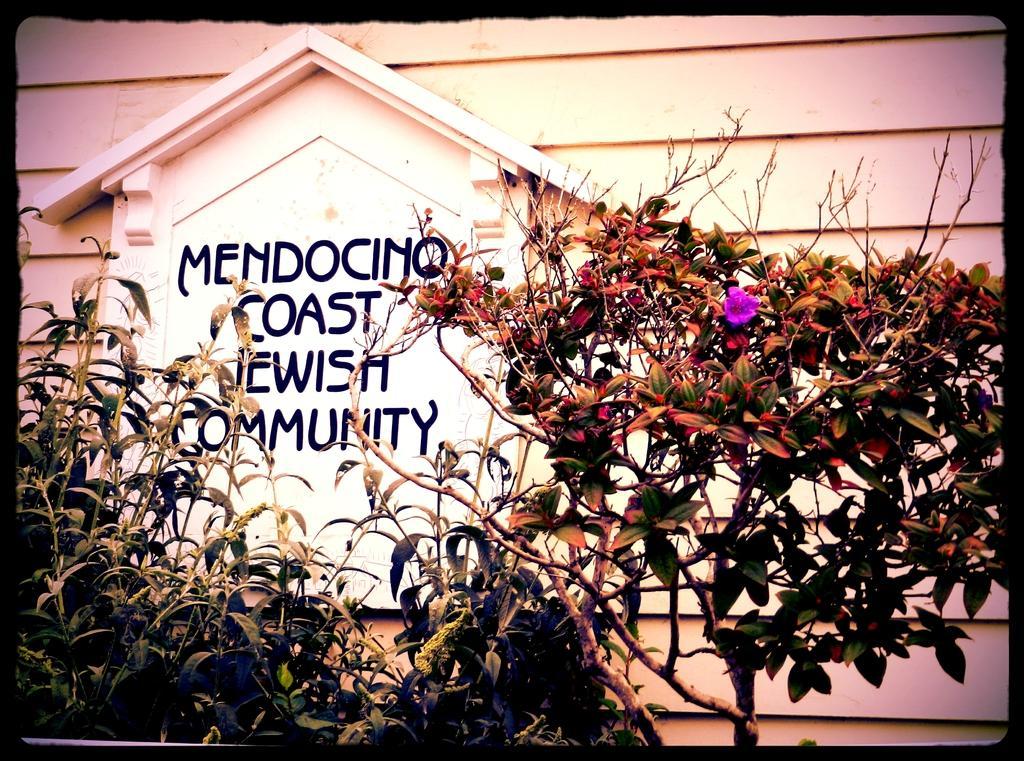In one or two sentences, can you explain what this image depicts? In this image we can see plants, background white color wall is there with some text written on it. 